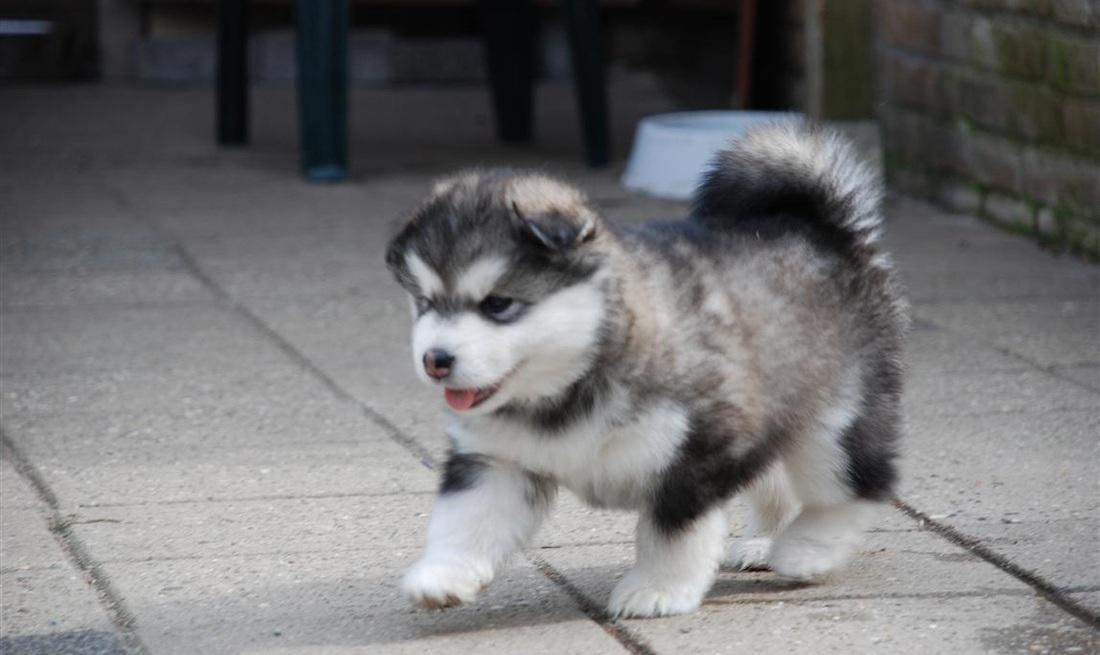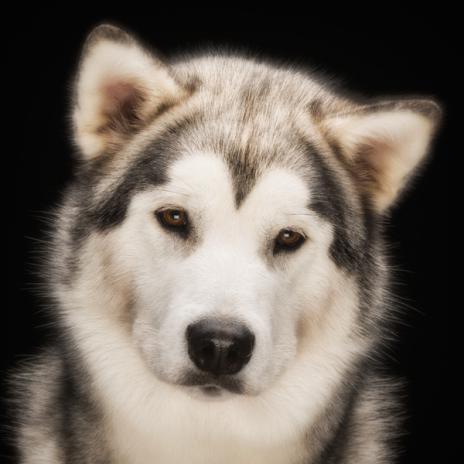The first image is the image on the left, the second image is the image on the right. Assess this claim about the two images: "The right image features two side-by-side forward-facing puppies with closed mouths.". Correct or not? Answer yes or no. No. 